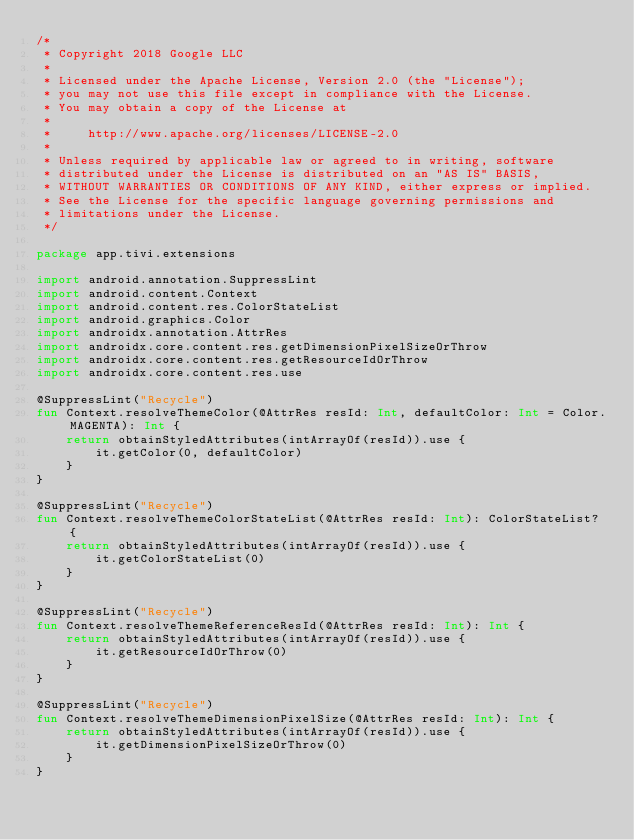<code> <loc_0><loc_0><loc_500><loc_500><_Kotlin_>/*
 * Copyright 2018 Google LLC
 *
 * Licensed under the Apache License, Version 2.0 (the "License");
 * you may not use this file except in compliance with the License.
 * You may obtain a copy of the License at
 *
 *     http://www.apache.org/licenses/LICENSE-2.0
 *
 * Unless required by applicable law or agreed to in writing, software
 * distributed under the License is distributed on an "AS IS" BASIS,
 * WITHOUT WARRANTIES OR CONDITIONS OF ANY KIND, either express or implied.
 * See the License for the specific language governing permissions and
 * limitations under the License.
 */

package app.tivi.extensions

import android.annotation.SuppressLint
import android.content.Context
import android.content.res.ColorStateList
import android.graphics.Color
import androidx.annotation.AttrRes
import androidx.core.content.res.getDimensionPixelSizeOrThrow
import androidx.core.content.res.getResourceIdOrThrow
import androidx.core.content.res.use

@SuppressLint("Recycle")
fun Context.resolveThemeColor(@AttrRes resId: Int, defaultColor: Int = Color.MAGENTA): Int {
    return obtainStyledAttributes(intArrayOf(resId)).use {
        it.getColor(0, defaultColor)
    }
}

@SuppressLint("Recycle")
fun Context.resolveThemeColorStateList(@AttrRes resId: Int): ColorStateList? {
    return obtainStyledAttributes(intArrayOf(resId)).use {
        it.getColorStateList(0)
    }
}

@SuppressLint("Recycle")
fun Context.resolveThemeReferenceResId(@AttrRes resId: Int): Int {
    return obtainStyledAttributes(intArrayOf(resId)).use {
        it.getResourceIdOrThrow(0)
    }
}

@SuppressLint("Recycle")
fun Context.resolveThemeDimensionPixelSize(@AttrRes resId: Int): Int {
    return obtainStyledAttributes(intArrayOf(resId)).use {
        it.getDimensionPixelSizeOrThrow(0)
    }
}</code> 